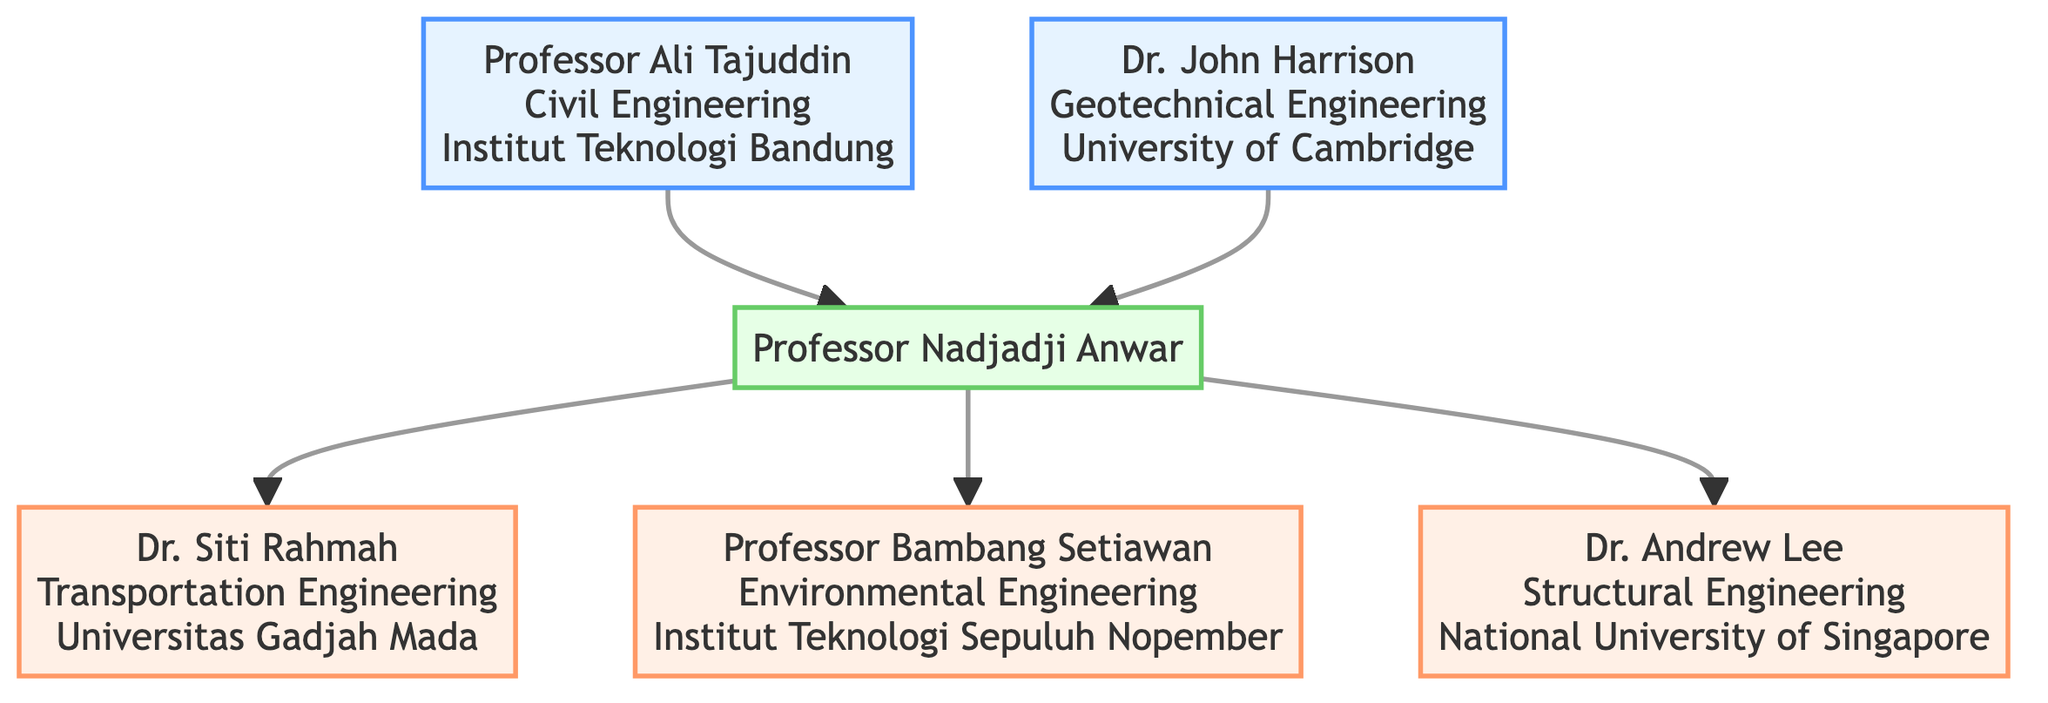What is the field of Professor Ali Tajuddin? The diagram indicates that Professor Ali Tajuddin is associated with Civil Engineering as mentioned in the node representing him.
Answer: Civil Engineering How many mentors does Professor Nadjadji Anwar have? By counting the nodes connected to Professor Nadjadji Anwar that are labeled as mentors, we find two nodes: Professor Ali Tajuddin and Dr. John Harrison.
Answer: 2 Who is a prominent student in Environmental Engineering? Looking at the node for prominent students, it is clear that Professor Bambang Setiawan is in the field of Environmental Engineering.
Answer: Professor Bambang Setiawan Which institution is associated with Dr. Andrew Lee? The diagram shows that Dr. Andrew Lee is linked to the National University of Singapore, which is specified in his node.
Answer: National University of Singapore What is Dr. Siti Rahmah's achievement? The node for Dr. Siti Rahmah states that she developed a new traffic flow model used in urban planning.
Answer: Developed a new traffic flow model used in urban planning Which mentor has a contribution to groundbreaking work on soil mechanics? The diagram specifies that Dr. John Harrison is the mentor known for groundbreaking work on soil mechanics in the Geotechnical Engineering field.
Answer: Dr. John Harrison How many prominent students are there in total? By looking at the connections branching out from Professor Nadjadji Anwar, we can count three prominent students: Dr. Siti Rahmah, Professor Bambang Setiawan, and Dr. Andrew Lee.
Answer: 3 Which mentor is associated with Institut Teknologi Bandung? The diagram clearly shows that Professor Ali Tajuddin is associated with Institut Teknologi Bandung based on the information presented in his node.
Answer: Professor Ali Tajuddin What is the relationship between Professor Nadjadji Anwar and Dr. Andrew Lee? The diagram illustrates that Professor Nadjadji Anwar is the mentor of Dr. Andrew Lee, as indicated by the direction of the connecting arrow from Anwar to Lee.
Answer: Mentor-mentee relationship 